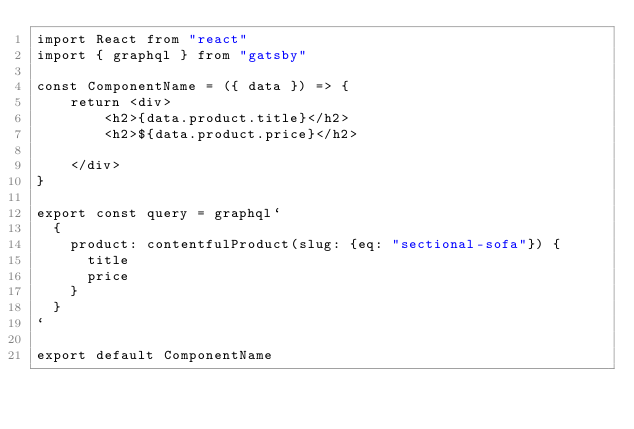Convert code to text. <code><loc_0><loc_0><loc_500><loc_500><_JavaScript_>import React from "react"
import { graphql } from "gatsby"

const ComponentName = ({ data }) => {
    return <div>
        <h2>{data.product.title}</h2>
        <h2>${data.product.price}</h2>

    </div>
}

export const query = graphql`
  {
    product: contentfulProduct(slug: {eq: "sectional-sofa"}) {
      title
      price
    }
  }
`

export default ComponentName</code> 